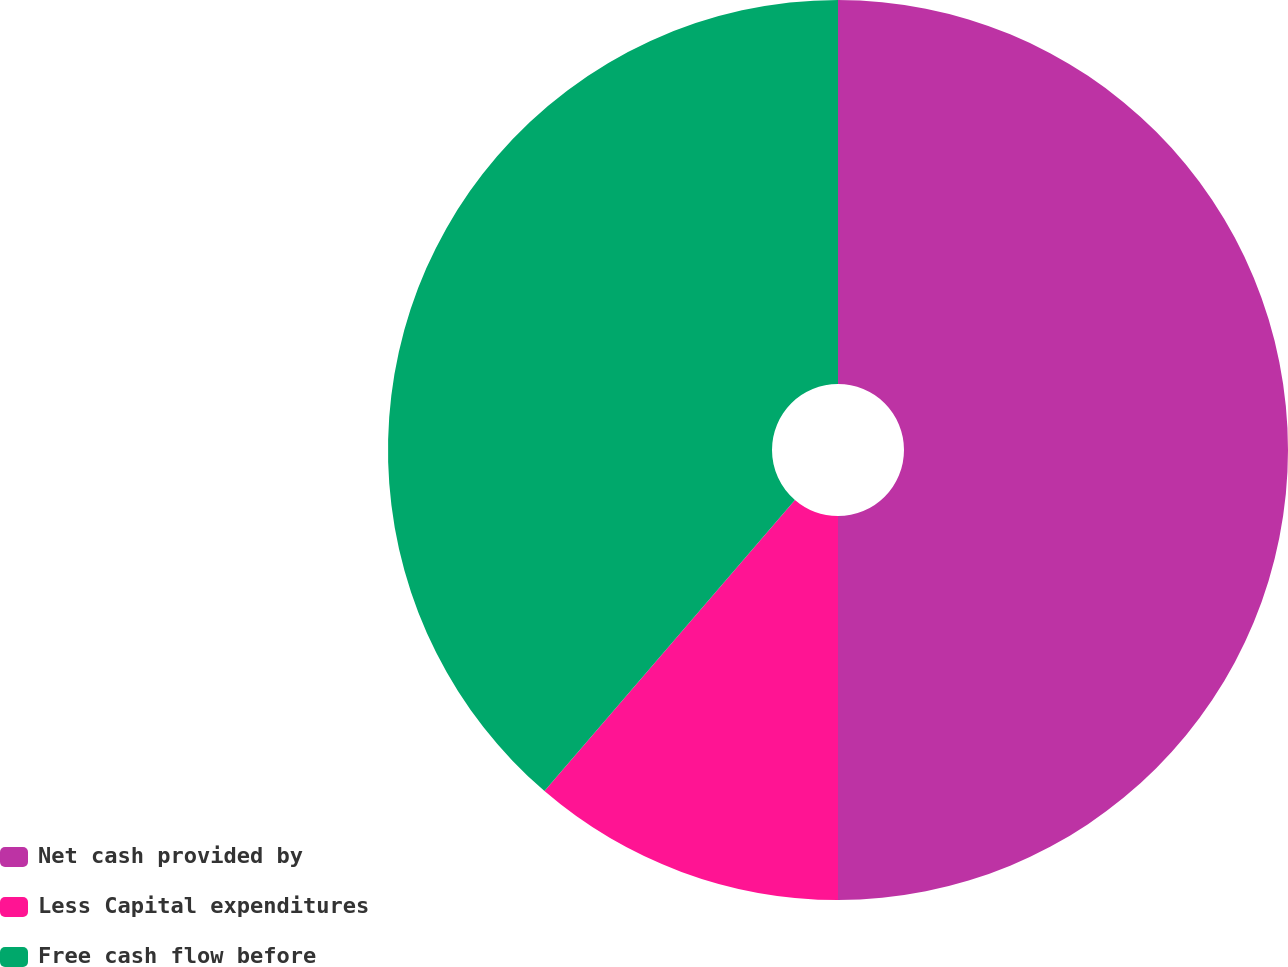Convert chart. <chart><loc_0><loc_0><loc_500><loc_500><pie_chart><fcel>Net cash provided by<fcel>Less Capital expenditures<fcel>Free cash flow before<nl><fcel>50.0%<fcel>11.31%<fcel>38.69%<nl></chart> 